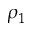Convert formula to latex. <formula><loc_0><loc_0><loc_500><loc_500>\rho _ { 1 }</formula> 